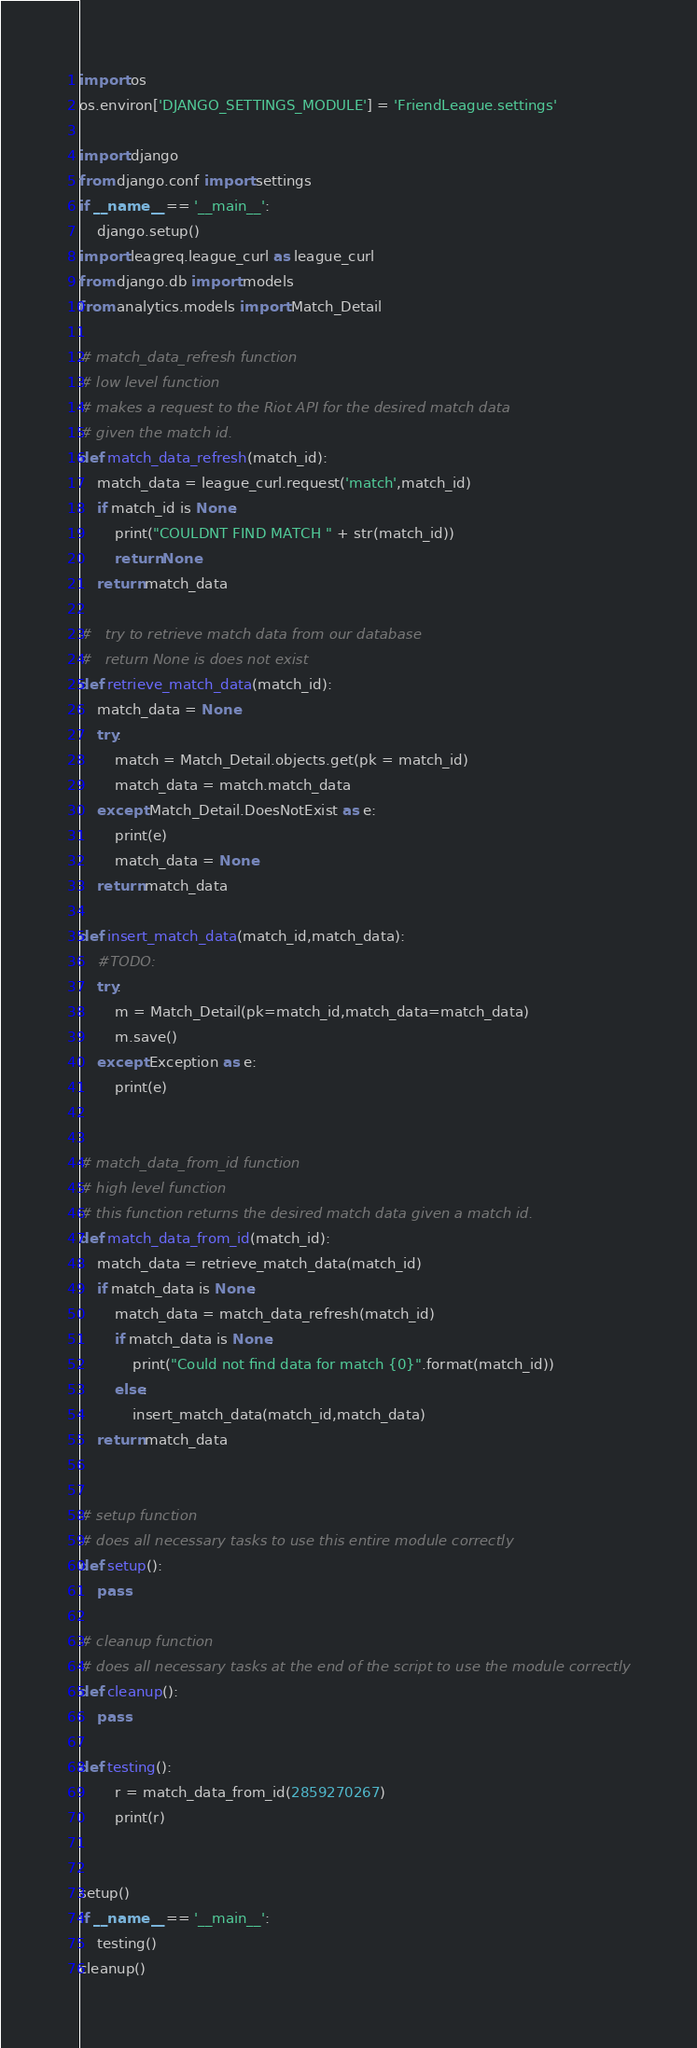Convert code to text. <code><loc_0><loc_0><loc_500><loc_500><_Python_>import os
os.environ['DJANGO_SETTINGS_MODULE'] = 'FriendLeague.settings'

import django
from django.conf import settings
if __name__ == '__main__':
    django.setup()
import leagreq.league_curl as league_curl
from django.db import models
from analytics.models import Match_Detail

# match_data_refresh function
# low level function
# makes a request to the Riot API for the desired match data
# given the match id.
def match_data_refresh(match_id):
    match_data = league_curl.request('match',match_id)
    if match_id is None:
        print("COULDNT FIND MATCH " + str(match_id))
        return None
    return match_data

#   try to retrieve match data from our database
#   return None is does not exist
def retrieve_match_data(match_id):
    match_data = None
    try:
        match = Match_Detail.objects.get(pk = match_id)
        match_data = match.match_data
    except Match_Detail.DoesNotExist as e:
        print(e)
        match_data = None
    return match_data

def insert_match_data(match_id,match_data):
    #TODO:
    try:
        m = Match_Detail(pk=match_id,match_data=match_data)
        m.save()
    except Exception as e:
        print(e)


# match_data_from_id function
# high level function
# this function returns the desired match data given a match id.
def match_data_from_id(match_id):
    match_data = retrieve_match_data(match_id)
    if match_data is None:
        match_data = match_data_refresh(match_id)
        if match_data is None:
            print("Could not find data for match {0}".format(match_id))
        else:
            insert_match_data(match_id,match_data)
    return match_data


# setup function
# does all necessary tasks to use this entire module correctly
def setup():
    pass

# cleanup function
# does all necessary tasks at the end of the script to use the module correctly
def cleanup():
    pass

def testing():
        r = match_data_from_id(2859270267)
        print(r)


setup()
if __name__ == '__main__':
    testing()
cleanup()
</code> 